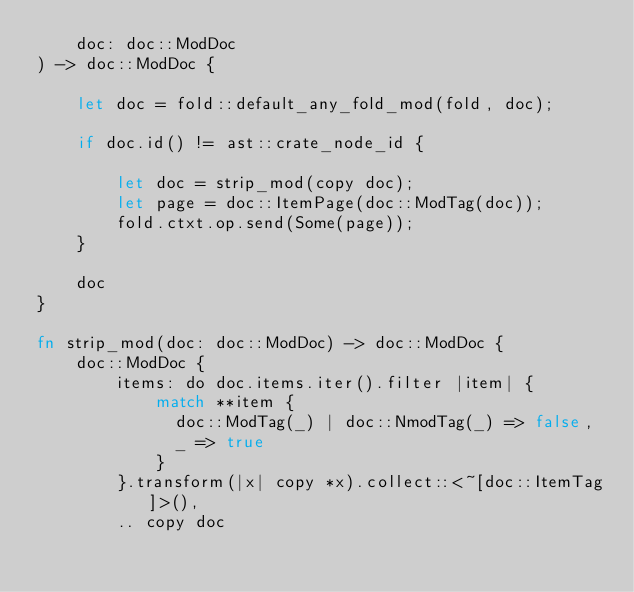<code> <loc_0><loc_0><loc_500><loc_500><_Rust_>    doc: doc::ModDoc
) -> doc::ModDoc {

    let doc = fold::default_any_fold_mod(fold, doc);

    if doc.id() != ast::crate_node_id {

        let doc = strip_mod(copy doc);
        let page = doc::ItemPage(doc::ModTag(doc));
        fold.ctxt.op.send(Some(page));
    }

    doc
}

fn strip_mod(doc: doc::ModDoc) -> doc::ModDoc {
    doc::ModDoc {
        items: do doc.items.iter().filter |item| {
            match **item {
              doc::ModTag(_) | doc::NmodTag(_) => false,
              _ => true
            }
        }.transform(|x| copy *x).collect::<~[doc::ItemTag]>(),
        .. copy doc</code> 